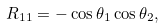<formula> <loc_0><loc_0><loc_500><loc_500>R _ { 1 1 } = - \cos \theta _ { 1 } \cos \theta _ { 2 } ,</formula> 